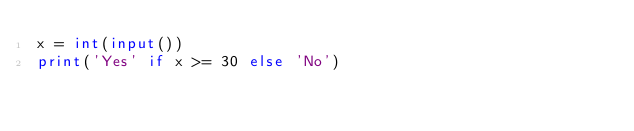<code> <loc_0><loc_0><loc_500><loc_500><_Python_>x = int(input())
print('Yes' if x >= 30 else 'No')
</code> 